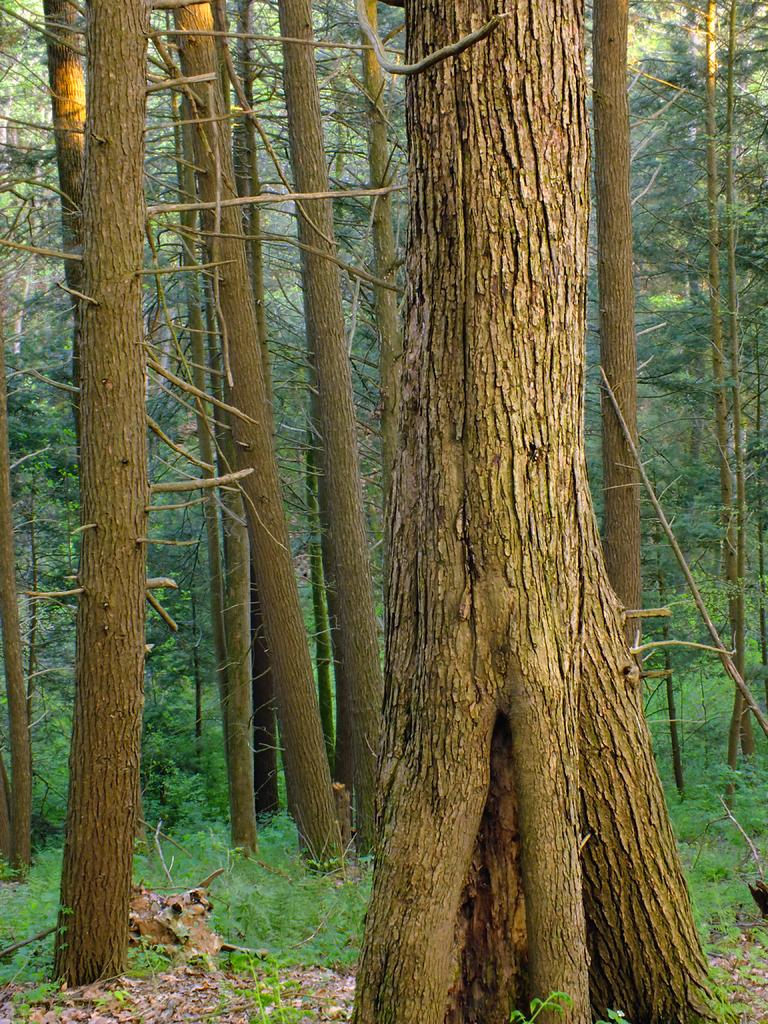What type of natural elements can be seen in the image? Tree trunks, plants, and trees can be seen in the image. Can you describe the tree trunks in the image? The tree trunks in the image are the main part of the trees, providing support and structure. What type of vegetation is present in the image? Plants and trees are present in the image. What type of condition is the boat in within the image? There is no boat present in the image. How many balls can be seen in the image? There are no balls present in the image. 